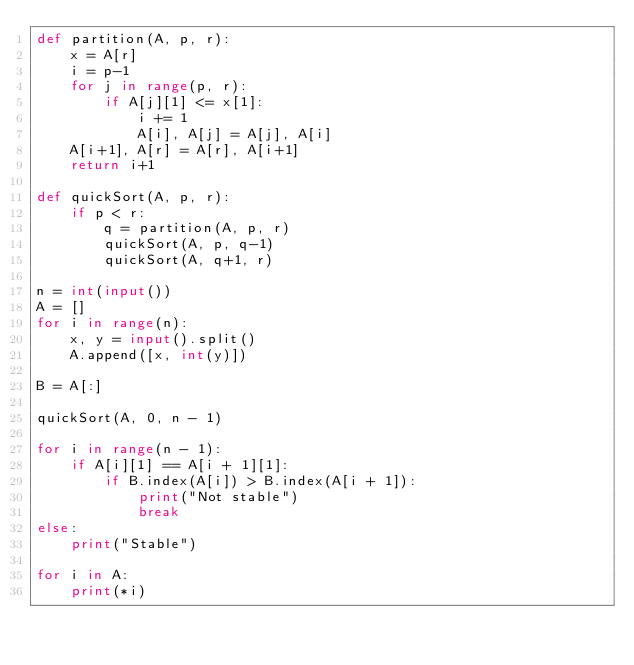<code> <loc_0><loc_0><loc_500><loc_500><_Python_>def partition(A, p, r):
    x = A[r]
    i = p-1
    for j in range(p, r):
        if A[j][1] <= x[1]:
            i += 1
            A[i], A[j] = A[j], A[i]
    A[i+1], A[r] = A[r], A[i+1]
    return i+1

def quickSort(A, p, r):
    if p < r:
        q = partition(A, p, r)
        quickSort(A, p, q-1)
        quickSort(A, q+1, r)

n = int(input())
A = []
for i in range(n):
    x, y = input().split()
    A.append([x, int(y)])
    
B = A[:]

quickSort(A, 0, n - 1)

for i in range(n - 1):
    if A[i][1] == A[i + 1][1]:
        if B.index(A[i]) > B.index(A[i + 1]):
            print("Not stable")
            break
else:
    print("Stable")
  
for i in A:
    print(*i)         
</code> 